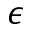<formula> <loc_0><loc_0><loc_500><loc_500>\epsilon</formula> 